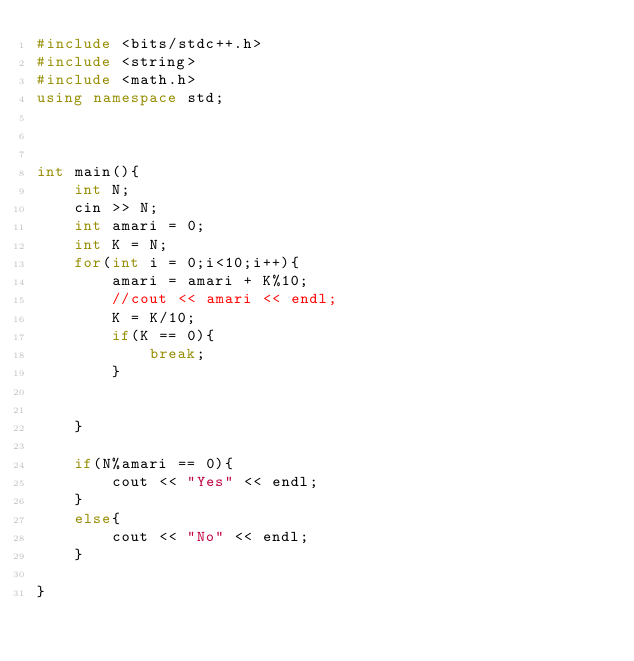Convert code to text. <code><loc_0><loc_0><loc_500><loc_500><_C++_>#include <bits/stdc++.h>
#include <string>
#include <math.h>
using namespace std;



int main(){
    int N;
    cin >> N;
    int amari = 0;
    int K = N;
    for(int i = 0;i<10;i++){
        amari = amari + K%10;
        //cout << amari << endl;
        K = K/10;
        if(K == 0){
            break;
        }
        
        
    }

    if(N%amari == 0){
        cout << "Yes" << endl;
    }
    else{
        cout << "No" << endl;
    }

}</code> 